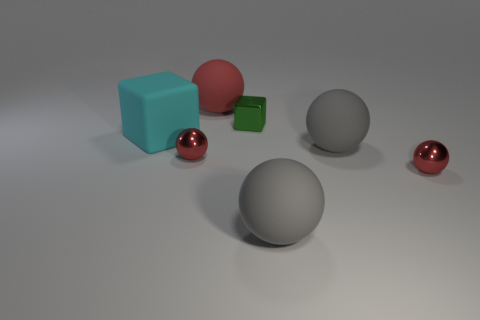Is there any lighting source visible or any indication of where the light might be coming from? No explicit light source is depicted within the image. However, reflections and shadows suggest an overhead lighting setup, possibly out of the frame, likely positioned above the scene to the left, highlighting the objects and creating soft shadows on the ground. 